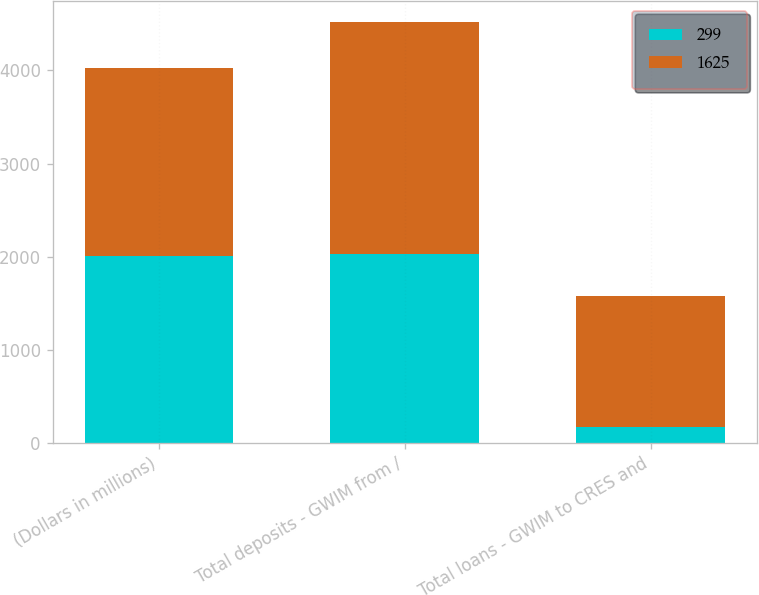<chart> <loc_0><loc_0><loc_500><loc_500><stacked_bar_chart><ecel><fcel>(Dollars in millions)<fcel>Total deposits - GWIM from /<fcel>Total loans - GWIM to CRES and<nl><fcel>299<fcel>2011<fcel>2032<fcel>174<nl><fcel>1625<fcel>2010<fcel>2486<fcel>1405<nl></chart> 